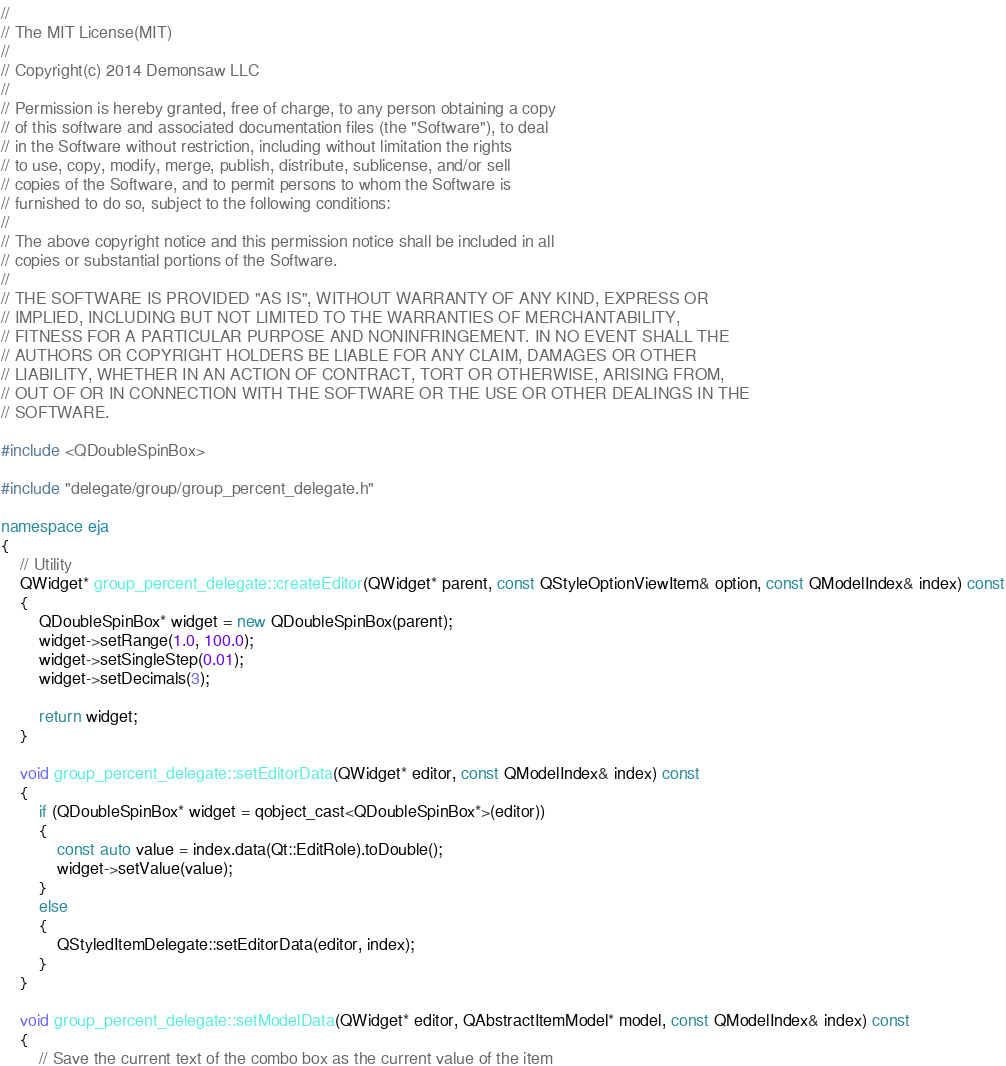<code> <loc_0><loc_0><loc_500><loc_500><_C++_>//
// The MIT License(MIT)
//
// Copyright(c) 2014 Demonsaw LLC
//
// Permission is hereby granted, free of charge, to any person obtaining a copy
// of this software and associated documentation files (the "Software"), to deal
// in the Software without restriction, including without limitation the rights
// to use, copy, modify, merge, publish, distribute, sublicense, and/or sell
// copies of the Software, and to permit persons to whom the Software is
// furnished to do so, subject to the following conditions:
// 
// The above copyright notice and this permission notice shall be included in all
// copies or substantial portions of the Software.
// 
// THE SOFTWARE IS PROVIDED "AS IS", WITHOUT WARRANTY OF ANY KIND, EXPRESS OR
// IMPLIED, INCLUDING BUT NOT LIMITED TO THE WARRANTIES OF MERCHANTABILITY,
// FITNESS FOR A PARTICULAR PURPOSE AND NONINFRINGEMENT. IN NO EVENT SHALL THE
// AUTHORS OR COPYRIGHT HOLDERS BE LIABLE FOR ANY CLAIM, DAMAGES OR OTHER
// LIABILITY, WHETHER IN AN ACTION OF CONTRACT, TORT OR OTHERWISE, ARISING FROM,
// OUT OF OR IN CONNECTION WITH THE SOFTWARE OR THE USE OR OTHER DEALINGS IN THE
// SOFTWARE.

#include <QDoubleSpinBox>

#include "delegate/group/group_percent_delegate.h"

namespace eja
{
	// Utility
	QWidget* group_percent_delegate::createEditor(QWidget* parent, const QStyleOptionViewItem& option, const QModelIndex& index) const
	{
		QDoubleSpinBox* widget = new QDoubleSpinBox(parent);
		widget->setRange(1.0, 100.0);		
		widget->setSingleStep(0.01);
		widget->setDecimals(3);

		return widget;
	}

	void group_percent_delegate::setEditorData(QWidget* editor, const QModelIndex& index) const
	{
		if (QDoubleSpinBox* widget = qobject_cast<QDoubleSpinBox*>(editor))
		{
			const auto value = index.data(Qt::EditRole).toDouble();
			widget->setValue(value);
		}
		else
		{
			QStyledItemDelegate::setEditorData(editor, index);
		}
	}

	void group_percent_delegate::setModelData(QWidget* editor, QAbstractItemModel* model, const QModelIndex& index) const
	{
		// Save the current text of the combo box as the current value of the item</code> 